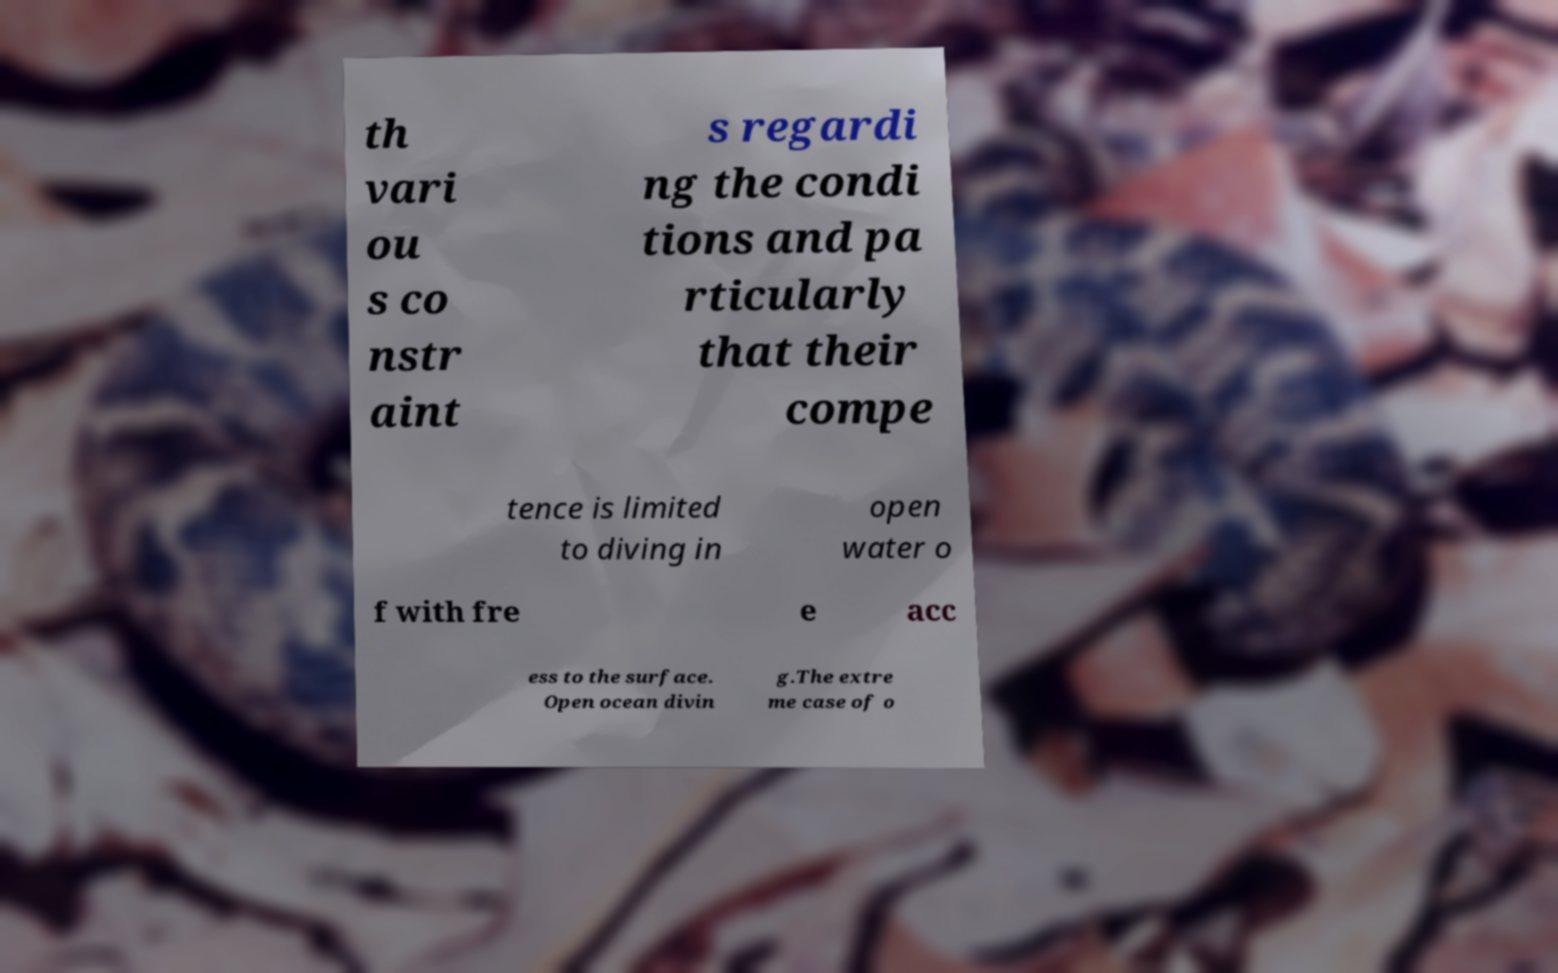Could you extract and type out the text from this image? th vari ou s co nstr aint s regardi ng the condi tions and pa rticularly that their compe tence is limited to diving in open water o f with fre e acc ess to the surface. Open ocean divin g.The extre me case of o 